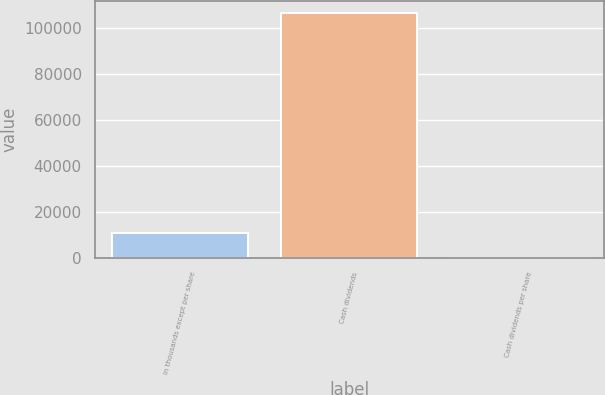Convert chart to OTSL. <chart><loc_0><loc_0><loc_500><loc_500><bar_chart><fcel>in thousands except per share<fcel>Cash dividends<fcel>Cash dividends per share<nl><fcel>10634<fcel>106333<fcel>0.8<nl></chart> 